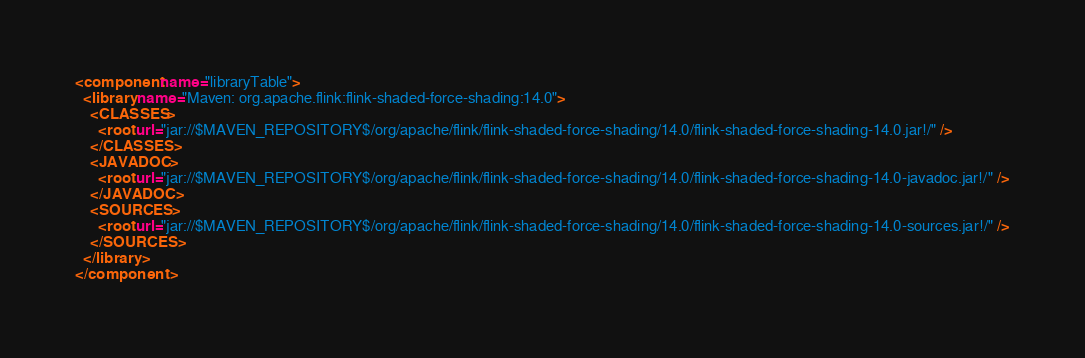Convert code to text. <code><loc_0><loc_0><loc_500><loc_500><_XML_><component name="libraryTable">
  <library name="Maven: org.apache.flink:flink-shaded-force-shading:14.0">
    <CLASSES>
      <root url="jar://$MAVEN_REPOSITORY$/org/apache/flink/flink-shaded-force-shading/14.0/flink-shaded-force-shading-14.0.jar!/" />
    </CLASSES>
    <JAVADOC>
      <root url="jar://$MAVEN_REPOSITORY$/org/apache/flink/flink-shaded-force-shading/14.0/flink-shaded-force-shading-14.0-javadoc.jar!/" />
    </JAVADOC>
    <SOURCES>
      <root url="jar://$MAVEN_REPOSITORY$/org/apache/flink/flink-shaded-force-shading/14.0/flink-shaded-force-shading-14.0-sources.jar!/" />
    </SOURCES>
  </library>
</component></code> 